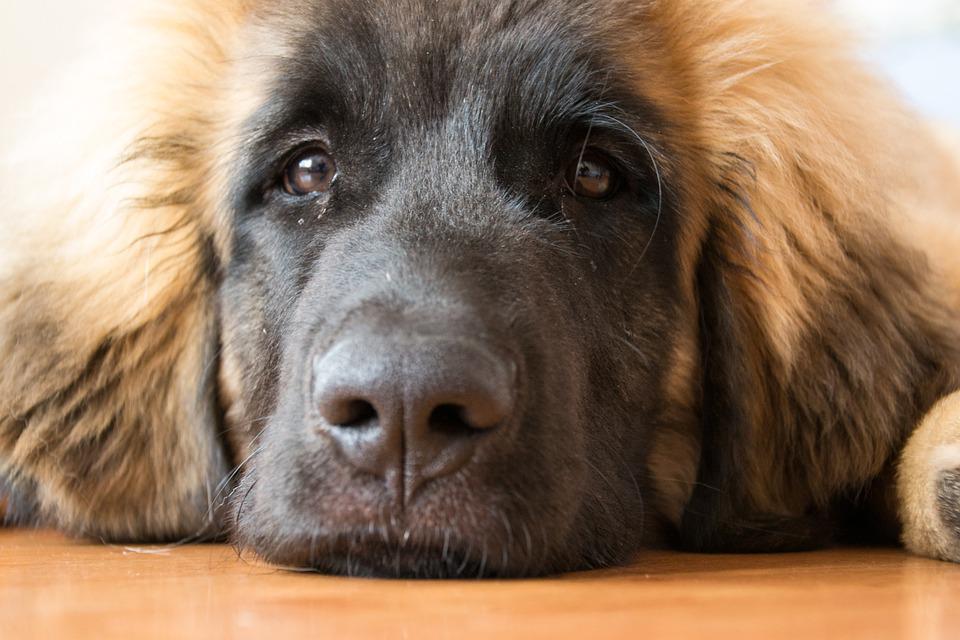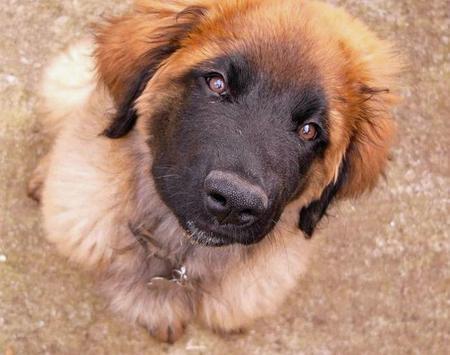The first image is the image on the left, the second image is the image on the right. Evaluate the accuracy of this statement regarding the images: "None of the dogs are alone and at least one of the dogs has a dark colored face.". Is it true? Answer yes or no. No. The first image is the image on the left, the second image is the image on the right. Evaluate the accuracy of this statement regarding the images: "A group of dogs is in the grass in at least one picture.". Is it true? Answer yes or no. No. 